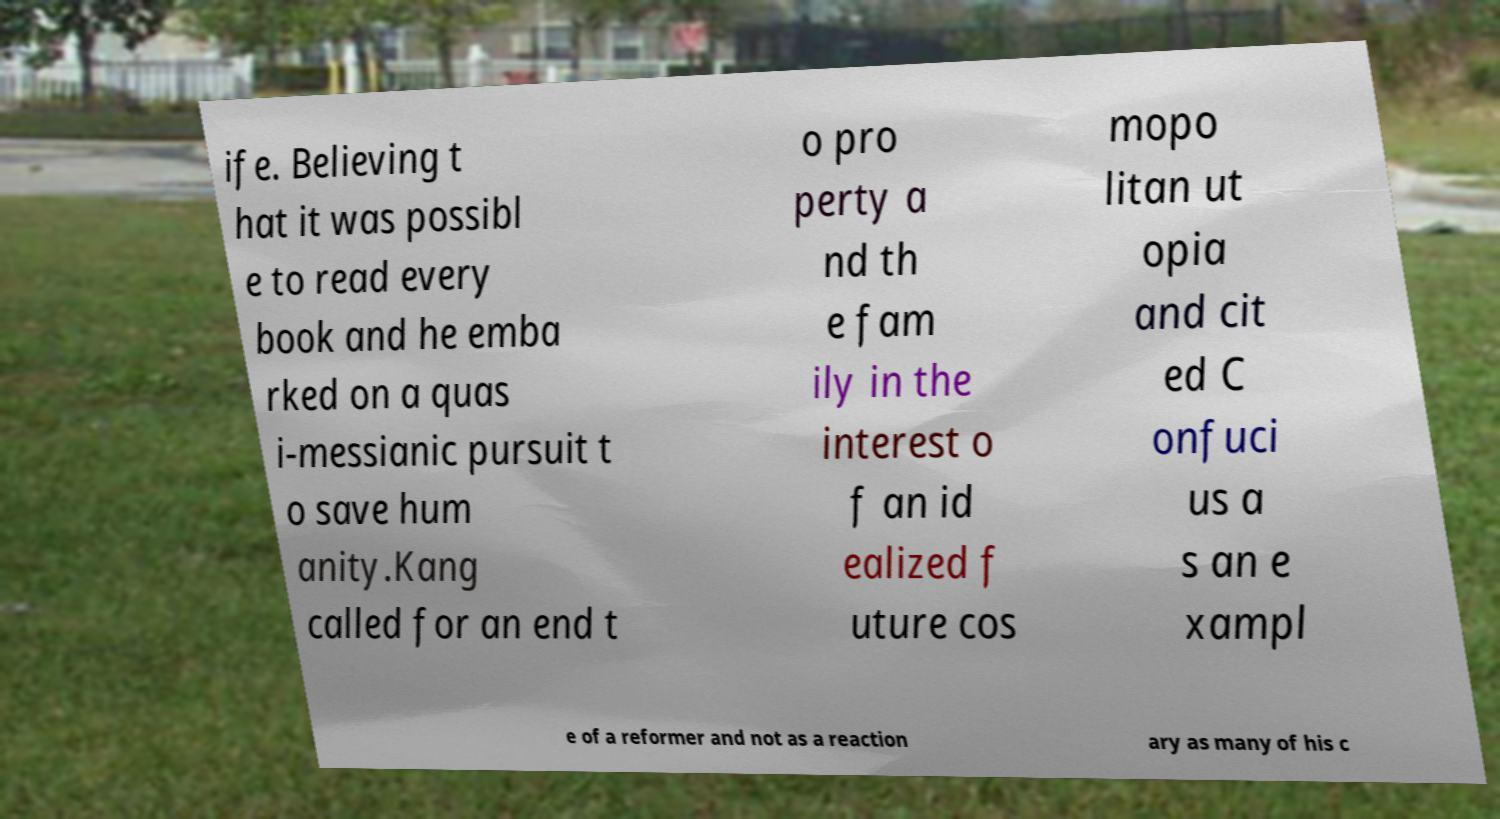Could you extract and type out the text from this image? ife. Believing t hat it was possibl e to read every book and he emba rked on a quas i-messianic pursuit t o save hum anity.Kang called for an end t o pro perty a nd th e fam ily in the interest o f an id ealized f uture cos mopo litan ut opia and cit ed C onfuci us a s an e xampl e of a reformer and not as a reaction ary as many of his c 